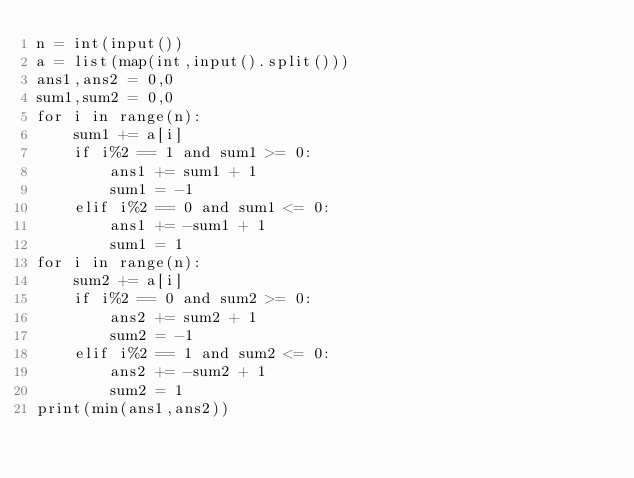Convert code to text. <code><loc_0><loc_0><loc_500><loc_500><_Python_>n = int(input())
a = list(map(int,input().split()))
ans1,ans2 = 0,0
sum1,sum2 = 0,0
for i in range(n):
    sum1 += a[i]
    if i%2 == 1 and sum1 >= 0:
        ans1 += sum1 + 1
        sum1 = -1
    elif i%2 == 0 and sum1 <= 0:
        ans1 += -sum1 + 1
        sum1 = 1
for i in range(n):
    sum2 += a[i]
    if i%2 == 0 and sum2 >= 0:
        ans2 += sum2 + 1
        sum2 = -1
    elif i%2 == 1 and sum2 <= 0:
        ans2 += -sum2 + 1
        sum2 = 1
print(min(ans1,ans2))
</code> 